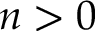Convert formula to latex. <formula><loc_0><loc_0><loc_500><loc_500>n > 0</formula> 